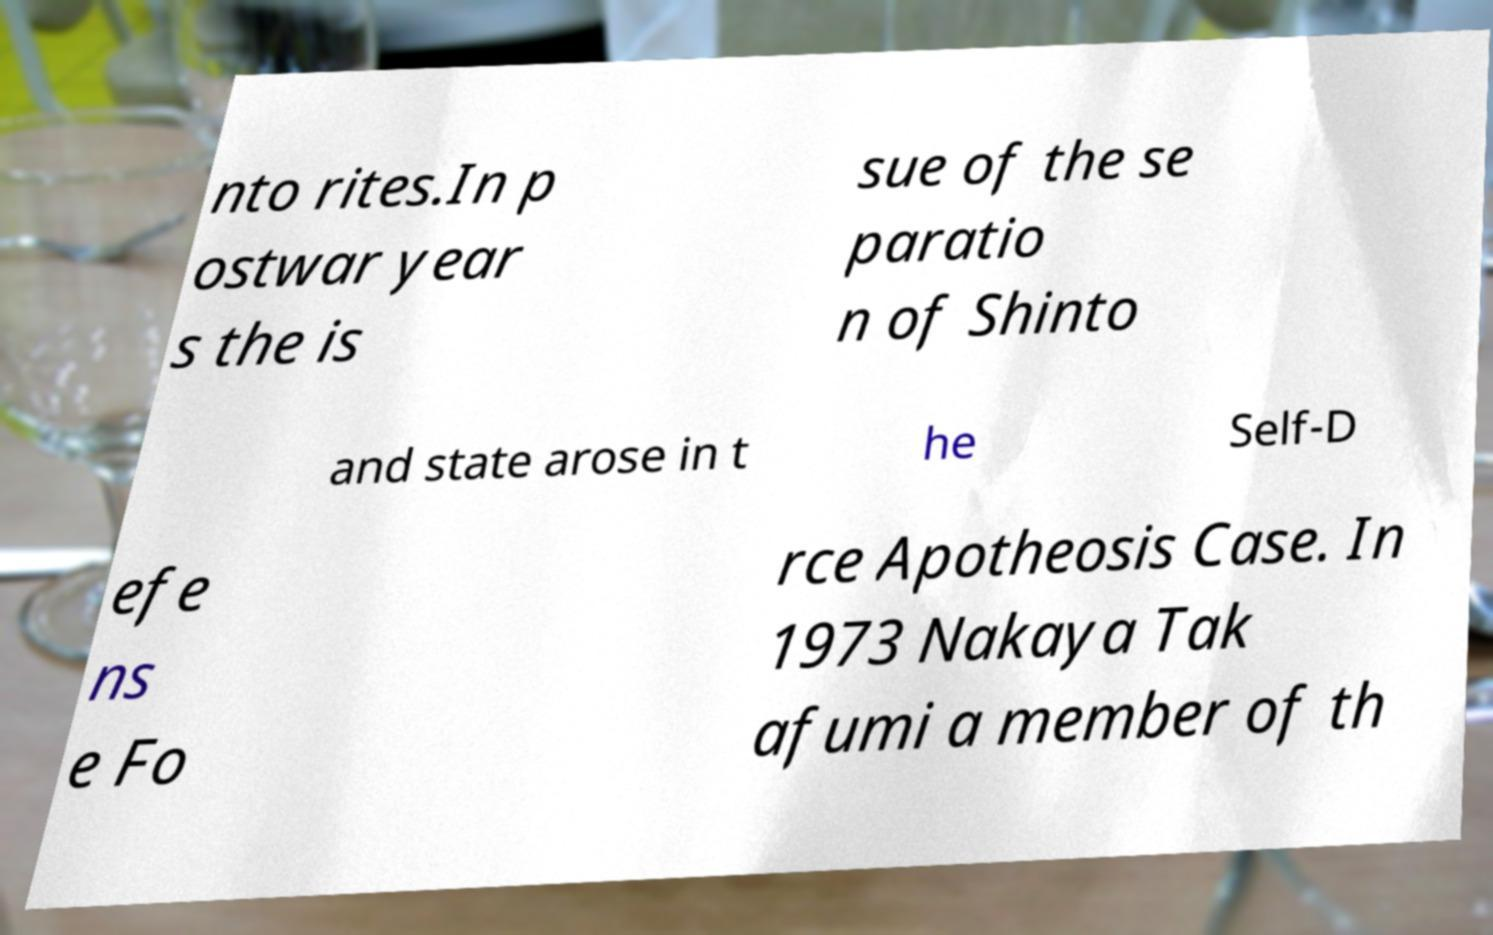Please read and relay the text visible in this image. What does it say? nto rites.In p ostwar year s the is sue of the se paratio n of Shinto and state arose in t he Self-D efe ns e Fo rce Apotheosis Case. In 1973 Nakaya Tak afumi a member of th 